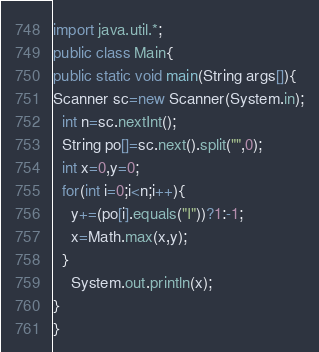Convert code to text. <code><loc_0><loc_0><loc_500><loc_500><_Java_>import java.util.*;
public class Main{
public static void main(String args[]){
Scanner sc=new Scanner(System.in);
  int n=sc.nextInt();
  String po[]=sc.next().split("",0);
  int x=0,y=0;
  for(int i=0;i<n;i++){
    y+=(po[i].equals("I"))?1:-1;
    x=Math.max(x,y);
  }
    System.out.println(x);
}
}
</code> 